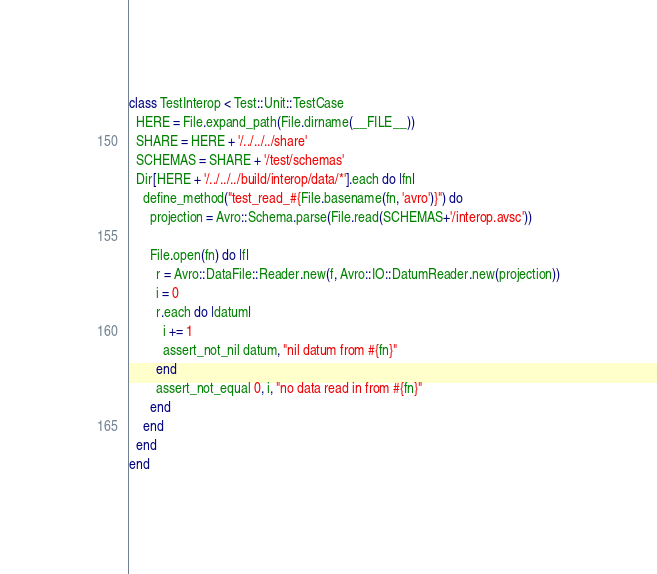<code> <loc_0><loc_0><loc_500><loc_500><_Ruby_>class TestInterop < Test::Unit::TestCase
  HERE = File.expand_path(File.dirname(__FILE__))
  SHARE = HERE + '/../../../share'
  SCHEMAS = SHARE + '/test/schemas'
  Dir[HERE + '/../../../build/interop/data/*'].each do |fn|
    define_method("test_read_#{File.basename(fn, 'avro')}") do
      projection = Avro::Schema.parse(File.read(SCHEMAS+'/interop.avsc'))

      File.open(fn) do |f|
        r = Avro::DataFile::Reader.new(f, Avro::IO::DatumReader.new(projection))
        i = 0
        r.each do |datum|
          i += 1
          assert_not_nil datum, "nil datum from #{fn}"
        end
        assert_not_equal 0, i, "no data read in from #{fn}"
      end
    end
  end
end
</code> 